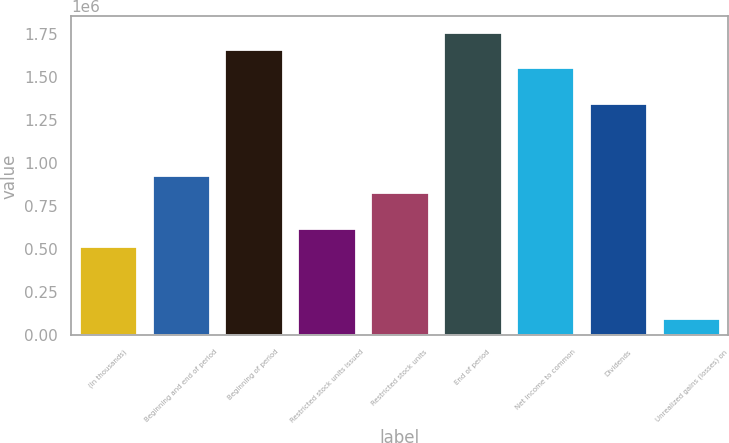Convert chart. <chart><loc_0><loc_0><loc_500><loc_500><bar_chart><fcel>(In thousands)<fcel>Beginning and end of period<fcel>Beginning of period<fcel>Restricted stock units issued<fcel>Restricted stock units<fcel>End of period<fcel>Net income to common<fcel>Dividends<fcel>Unrealized gains (losses) on<nl><fcel>518752<fcel>933707<fcel>1.65988e+06<fcel>622491<fcel>829969<fcel>1.76362e+06<fcel>1.55614e+06<fcel>1.34866e+06<fcel>103798<nl></chart> 